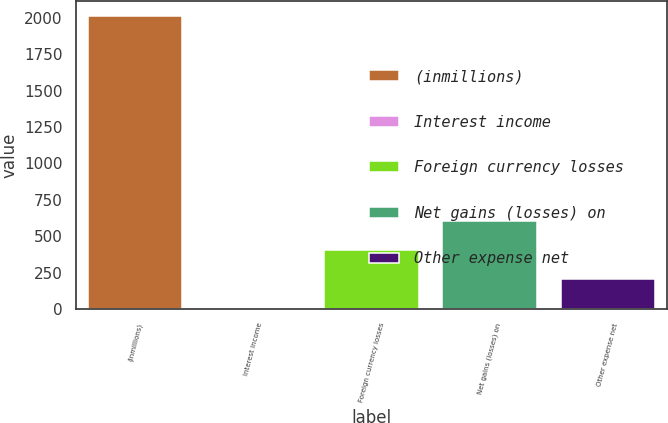Convert chart. <chart><loc_0><loc_0><loc_500><loc_500><bar_chart><fcel>(inmillions)<fcel>Interest income<fcel>Foreign currency losses<fcel>Net gains (losses) on<fcel>Other expense net<nl><fcel>2014<fcel>5<fcel>406.8<fcel>607.7<fcel>205.9<nl></chart> 